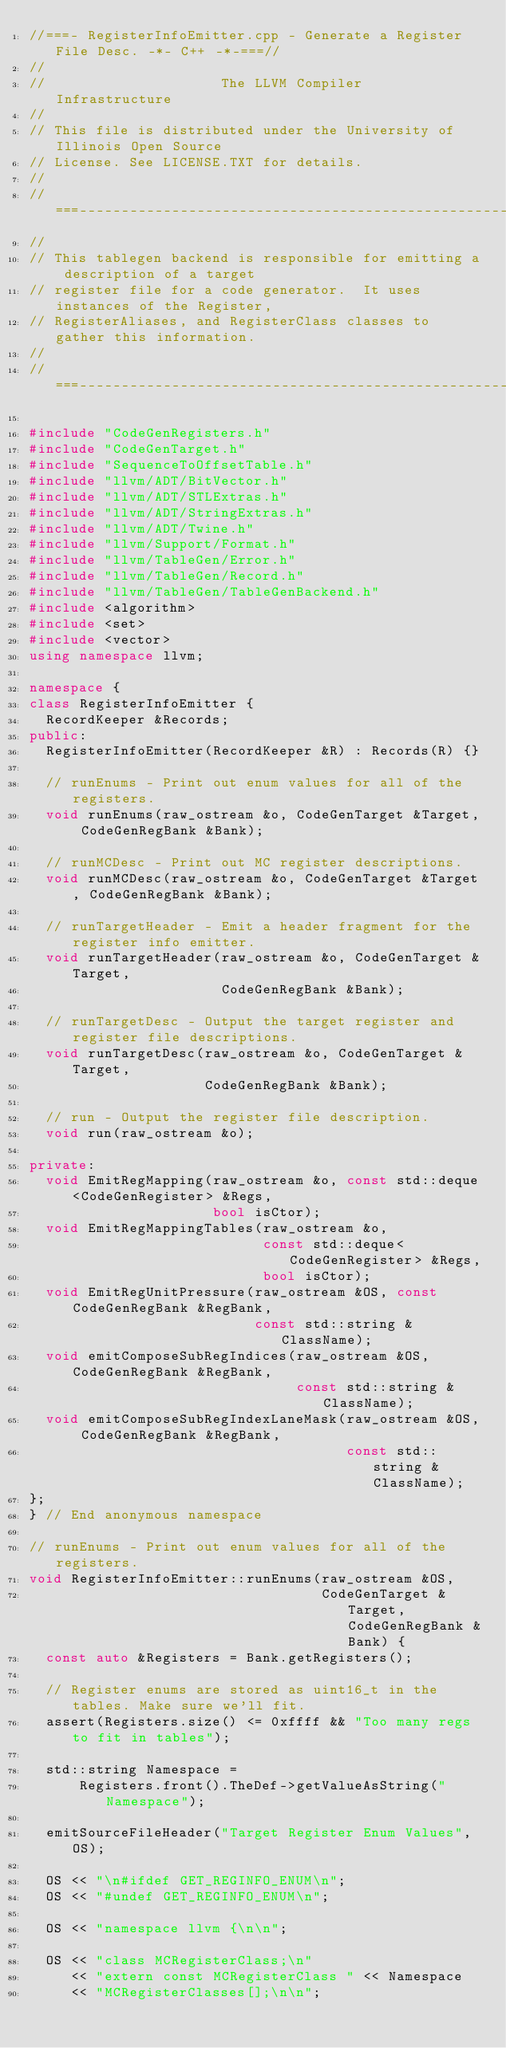Convert code to text. <code><loc_0><loc_0><loc_500><loc_500><_C++_>//===- RegisterInfoEmitter.cpp - Generate a Register File Desc. -*- C++ -*-===//
//
//                     The LLVM Compiler Infrastructure
//
// This file is distributed under the University of Illinois Open Source
// License. See LICENSE.TXT for details.
//
//===----------------------------------------------------------------------===//
//
// This tablegen backend is responsible for emitting a description of a target
// register file for a code generator.  It uses instances of the Register,
// RegisterAliases, and RegisterClass classes to gather this information.
//
//===----------------------------------------------------------------------===//

#include "CodeGenRegisters.h"
#include "CodeGenTarget.h"
#include "SequenceToOffsetTable.h"
#include "llvm/ADT/BitVector.h"
#include "llvm/ADT/STLExtras.h"
#include "llvm/ADT/StringExtras.h"
#include "llvm/ADT/Twine.h"
#include "llvm/Support/Format.h"
#include "llvm/TableGen/Error.h"
#include "llvm/TableGen/Record.h"
#include "llvm/TableGen/TableGenBackend.h"
#include <algorithm>
#include <set>
#include <vector>
using namespace llvm;

namespace {
class RegisterInfoEmitter {
  RecordKeeper &Records;
public:
  RegisterInfoEmitter(RecordKeeper &R) : Records(R) {}

  // runEnums - Print out enum values for all of the registers.
  void runEnums(raw_ostream &o, CodeGenTarget &Target, CodeGenRegBank &Bank);

  // runMCDesc - Print out MC register descriptions.
  void runMCDesc(raw_ostream &o, CodeGenTarget &Target, CodeGenRegBank &Bank);

  // runTargetHeader - Emit a header fragment for the register info emitter.
  void runTargetHeader(raw_ostream &o, CodeGenTarget &Target,
                       CodeGenRegBank &Bank);

  // runTargetDesc - Output the target register and register file descriptions.
  void runTargetDesc(raw_ostream &o, CodeGenTarget &Target,
                     CodeGenRegBank &Bank);

  // run - Output the register file description.
  void run(raw_ostream &o);

private:
  void EmitRegMapping(raw_ostream &o, const std::deque<CodeGenRegister> &Regs,
                      bool isCtor);
  void EmitRegMappingTables(raw_ostream &o,
                            const std::deque<CodeGenRegister> &Regs,
                            bool isCtor);
  void EmitRegUnitPressure(raw_ostream &OS, const CodeGenRegBank &RegBank,
                           const std::string &ClassName);
  void emitComposeSubRegIndices(raw_ostream &OS, CodeGenRegBank &RegBank,
                                const std::string &ClassName);
  void emitComposeSubRegIndexLaneMask(raw_ostream &OS, CodeGenRegBank &RegBank,
                                      const std::string &ClassName);
};
} // End anonymous namespace

// runEnums - Print out enum values for all of the registers.
void RegisterInfoEmitter::runEnums(raw_ostream &OS,
                                   CodeGenTarget &Target, CodeGenRegBank &Bank) {
  const auto &Registers = Bank.getRegisters();

  // Register enums are stored as uint16_t in the tables. Make sure we'll fit.
  assert(Registers.size() <= 0xffff && "Too many regs to fit in tables");

  std::string Namespace =
      Registers.front().TheDef->getValueAsString("Namespace");

  emitSourceFileHeader("Target Register Enum Values", OS);

  OS << "\n#ifdef GET_REGINFO_ENUM\n";
  OS << "#undef GET_REGINFO_ENUM\n";

  OS << "namespace llvm {\n\n";

  OS << "class MCRegisterClass;\n"
     << "extern const MCRegisterClass " << Namespace
     << "MCRegisterClasses[];\n\n";
</code> 